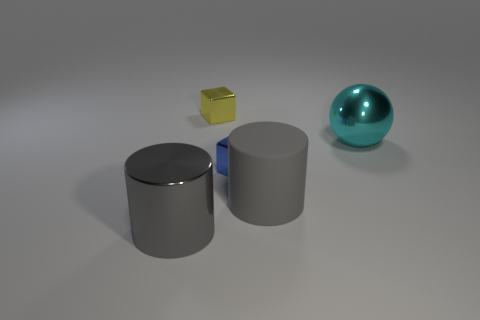Add 5 gray cylinders. How many objects exist? 10 Subtract all balls. How many objects are left? 4 Subtract all gray objects. Subtract all small gray matte cylinders. How many objects are left? 3 Add 3 gray objects. How many gray objects are left? 5 Add 5 tiny metal balls. How many tiny metal balls exist? 5 Subtract 0 red spheres. How many objects are left? 5 